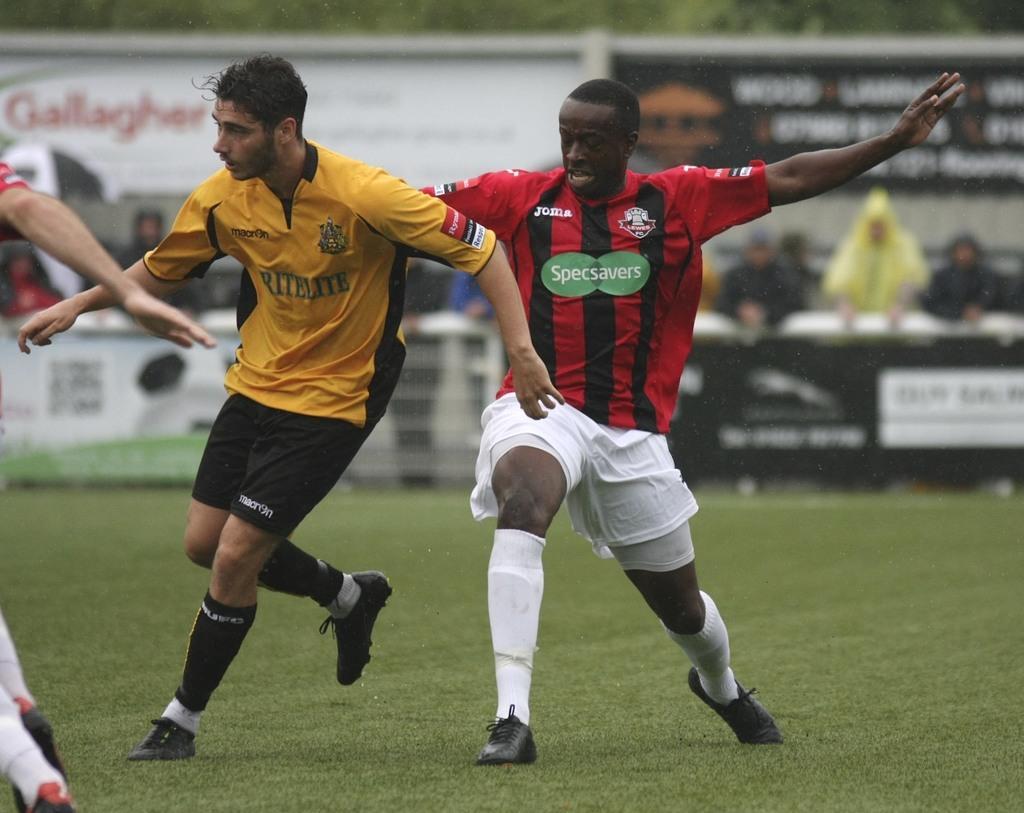Describe this image in one or two sentences. In this image we can see two football players on the ground. Here we can see the hand of a person on the left side. In the background, we can see a few spectators. Here we can see the hoardings. 